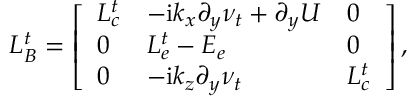Convert formula to latex. <formula><loc_0><loc_0><loc_500><loc_500>L _ { B } ^ { t } = \left [ \begin{array} { l l l } { L _ { c } ^ { t } } & { - i k _ { x } \partial _ { y } \nu _ { t } + \partial _ { y } U } & { 0 } \\ { 0 } & { L _ { e } ^ { t } - E _ { e } } & { 0 } \\ { 0 } & { - i k _ { z } \partial _ { y } \nu _ { t } } & { L _ { c } ^ { t } } \end{array} \right ] ,</formula> 